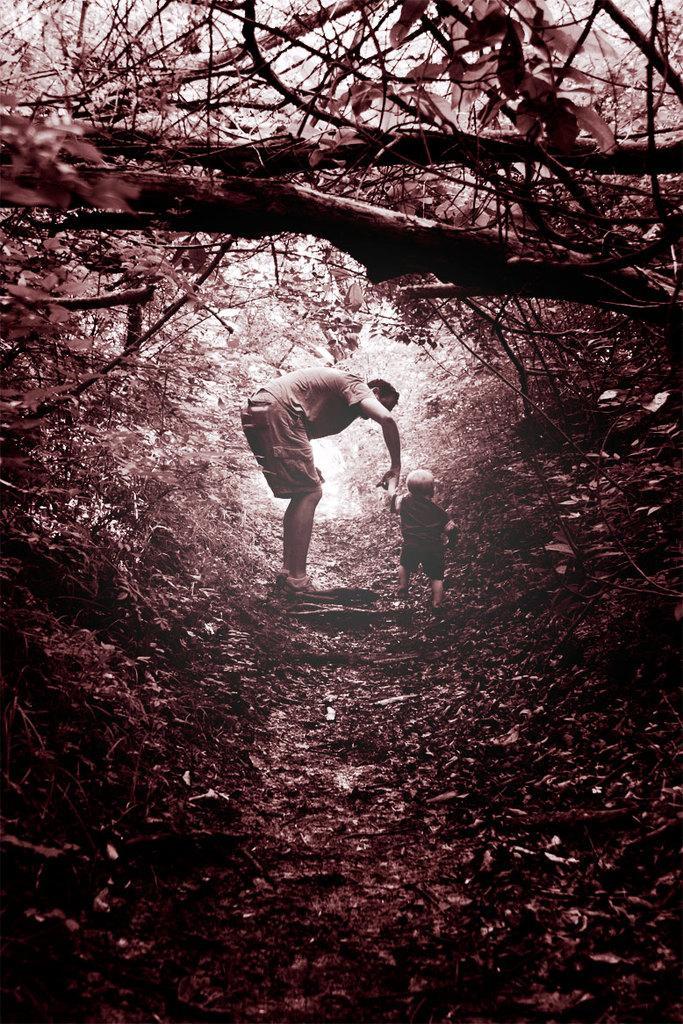Describe this image in one or two sentences. In this image in the center there is one person who is holding one boy's hand and walking. At the bottom there is walkway and some dry leaves, and on the right side and left side there are trees. 